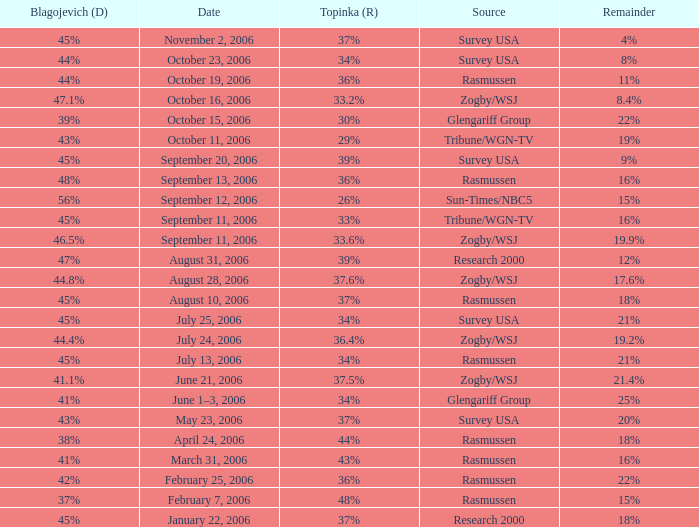Which Source has a Remainder of 15%, and a Topinka of 26%? Sun-Times/NBC5. 